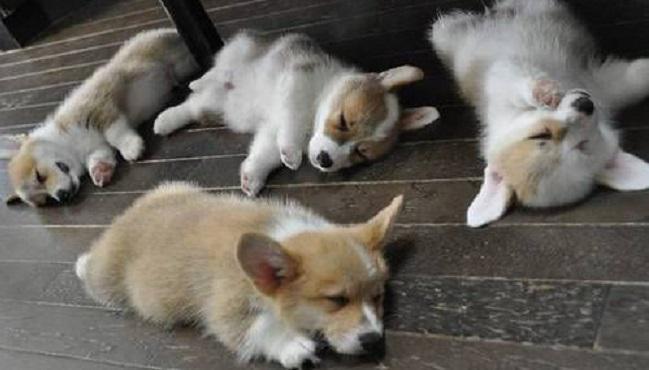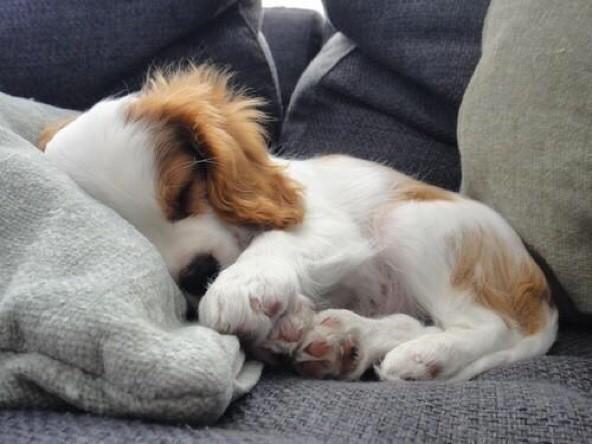The first image is the image on the left, the second image is the image on the right. Assess this claim about the two images: "An image shows exactly one short-legged dog, which is standing in the grass.". Correct or not? Answer yes or no. No. The first image is the image on the left, the second image is the image on the right. Analyze the images presented: Is the assertion "At least one dog has its tongue sticking out of its mouth." valid? Answer yes or no. No. 